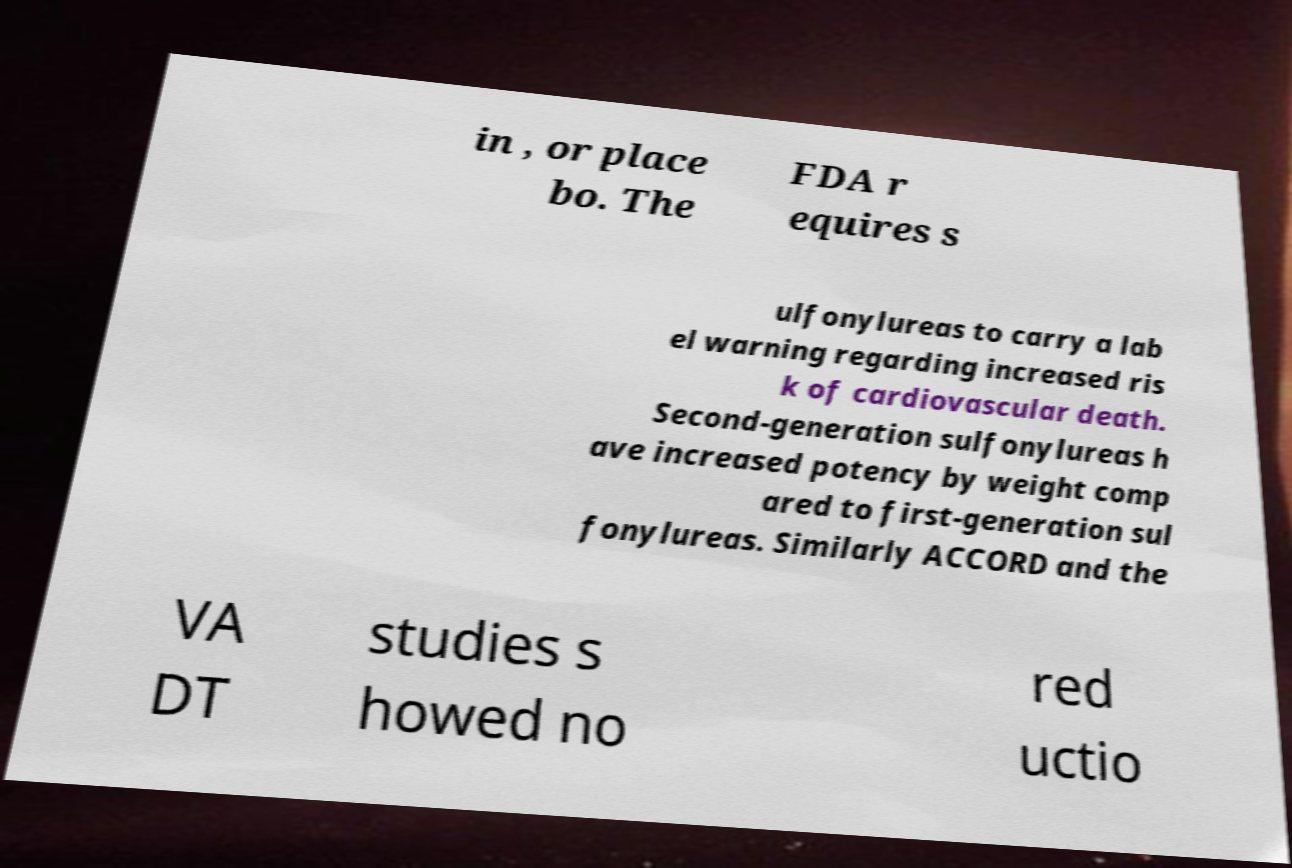Can you read and provide the text displayed in the image?This photo seems to have some interesting text. Can you extract and type it out for me? in , or place bo. The FDA r equires s ulfonylureas to carry a lab el warning regarding increased ris k of cardiovascular death. Second-generation sulfonylureas h ave increased potency by weight comp ared to first-generation sul fonylureas. Similarly ACCORD and the VA DT studies s howed no red uctio 